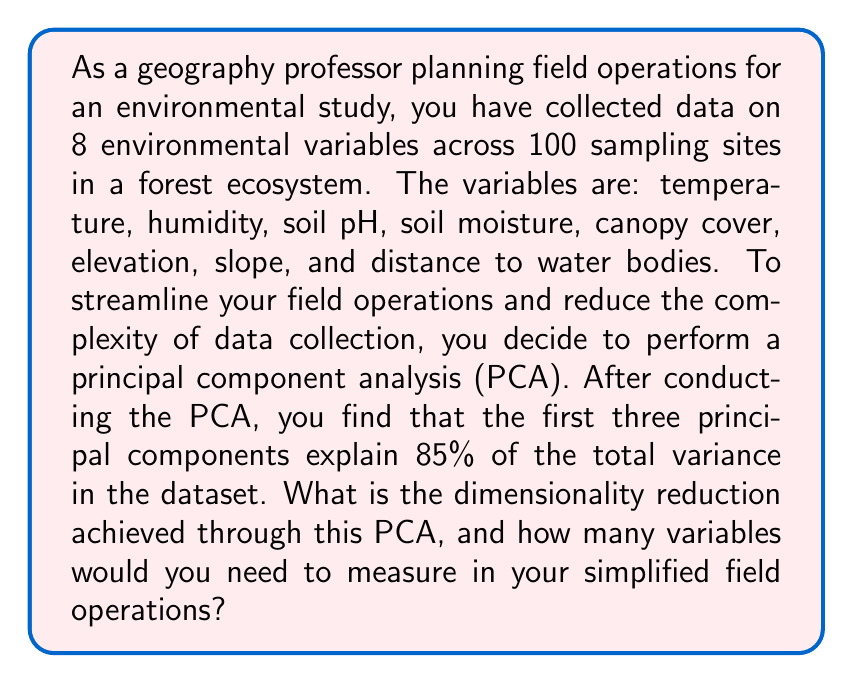Give your solution to this math problem. To solve this problem, we need to understand the concept of dimensionality reduction through PCA and how it applies to field operations in geography. Let's break it down step-by-step:

1. Initial dimensionality:
   We start with 8 environmental variables, so the initial dimensionality is 8.

2. PCA results:
   The first three principal components explain 85% of the total variance. This means we can capture most of the information in the dataset using just these three components.

3. Dimensionality reduction:
   The dimensionality reduction is calculated as the difference between the initial number of variables and the number of principal components retained:

   $$ \text{Dimensionality Reduction} = \text{Initial Variables} - \text{Retained Principal Components} $$
   $$ \text{Dimensionality Reduction} = 8 - 3 = 5 $$

4. Simplified field operations:
   In the simplified field operations, you would need to measure the three new variables represented by the first three principal components. These new variables are linear combinations of the original 8 variables.

5. Interpretation for field operations:
   By reducing the dimensionality from 8 to 3, you can significantly streamline your data collection process. Instead of measuring 8 separate variables at each sampling site, you would only need to collect data for 3 composite variables that capture the most important patterns in your study area.

6. Practical implementation:
   To use this in the field, you would need to:
   a) Calculate the loadings of each original variable on the three principal components.
   b) Create a data collection protocol that combines measurements of the original variables according to these loadings.
   c) Train field personnel to collect data using this new protocol.

This approach allows for more efficient field operations while still capturing the majority of the environmental variation in your study area.
Answer: The dimensionality reduction achieved through PCA is 5 (from 8 original variables to 3 principal components). In simplified field operations, you would need to measure 3 new composite variables represented by the first three principal components. 